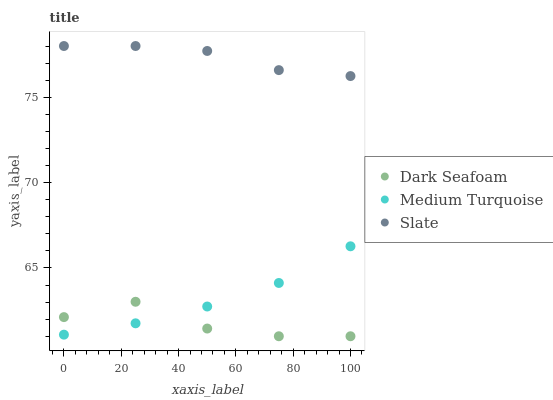Does Dark Seafoam have the minimum area under the curve?
Answer yes or no. Yes. Does Slate have the maximum area under the curve?
Answer yes or no. Yes. Does Medium Turquoise have the minimum area under the curve?
Answer yes or no. No. Does Medium Turquoise have the maximum area under the curve?
Answer yes or no. No. Is Medium Turquoise the smoothest?
Answer yes or no. Yes. Is Dark Seafoam the roughest?
Answer yes or no. Yes. Is Slate the smoothest?
Answer yes or no. No. Is Slate the roughest?
Answer yes or no. No. Does Dark Seafoam have the lowest value?
Answer yes or no. Yes. Does Medium Turquoise have the lowest value?
Answer yes or no. No. Does Slate have the highest value?
Answer yes or no. Yes. Does Medium Turquoise have the highest value?
Answer yes or no. No. Is Medium Turquoise less than Slate?
Answer yes or no. Yes. Is Slate greater than Dark Seafoam?
Answer yes or no. Yes. Does Dark Seafoam intersect Medium Turquoise?
Answer yes or no. Yes. Is Dark Seafoam less than Medium Turquoise?
Answer yes or no. No. Is Dark Seafoam greater than Medium Turquoise?
Answer yes or no. No. Does Medium Turquoise intersect Slate?
Answer yes or no. No. 